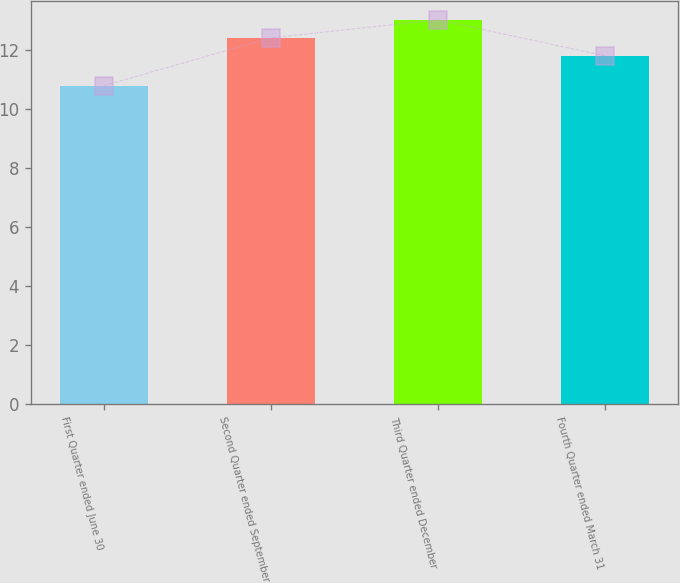Convert chart. <chart><loc_0><loc_0><loc_500><loc_500><bar_chart><fcel>First Quarter ended June 30<fcel>Second Quarter ended September<fcel>Third Quarter ended December<fcel>Fourth Quarter ended March 31<nl><fcel>10.8<fcel>12.42<fcel>13.03<fcel>11.81<nl></chart> 